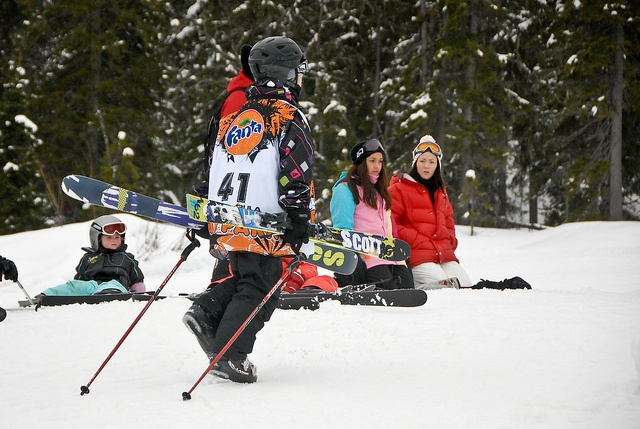Describe the objects in this image and their specific colors. I can see people in black, lavender, gray, and red tones, people in black, lightpink, gray, and lightblue tones, skis in black, gray, lightgray, and darkgray tones, people in black, brown, and lightgray tones, and people in black, gray, and lightblue tones in this image. 